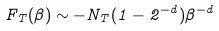<formula> <loc_0><loc_0><loc_500><loc_500>F _ { T } ( \beta ) \sim - N _ { T } ( 1 - 2 ^ { - d } ) \beta ^ { - d }</formula> 